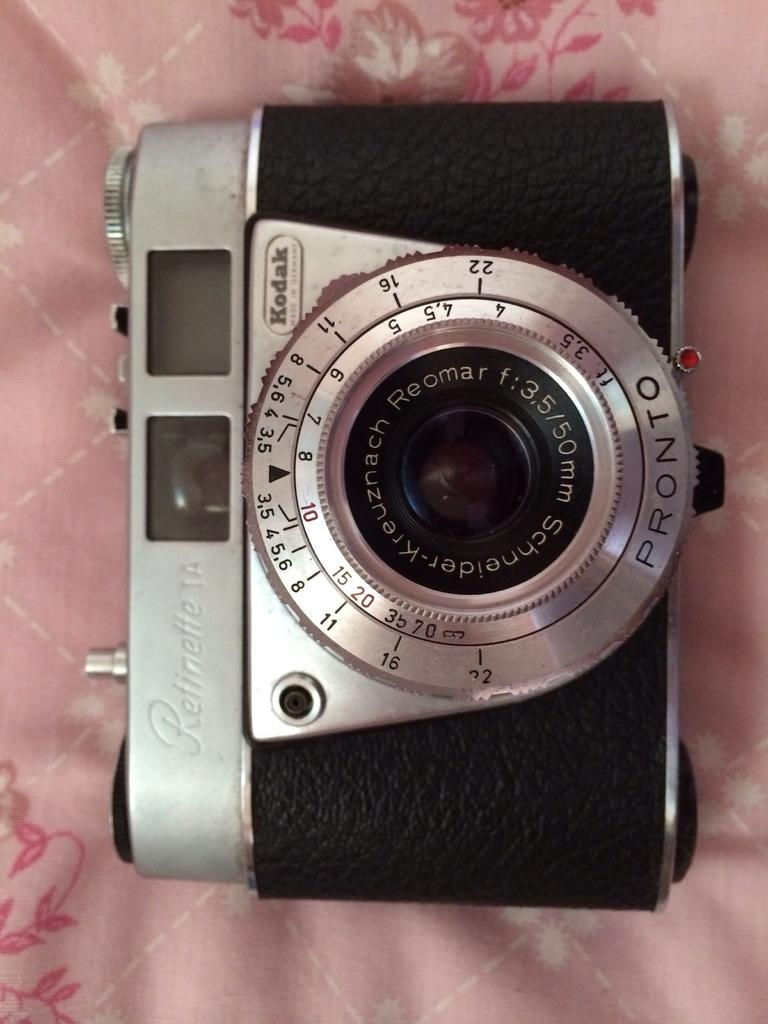What is the main object in the image? There is a camera in the image. What color is the surface the camera is on? The camera is on a pink surface. What feature of the camera is visible in the image? There are lenses on the camera. How many birds are flying over the camera in the image? There are no birds present in the image. What type of wave can be seen crashing on the camera in the image? There is no wave present in the image; it is a camera on a pink surface. 